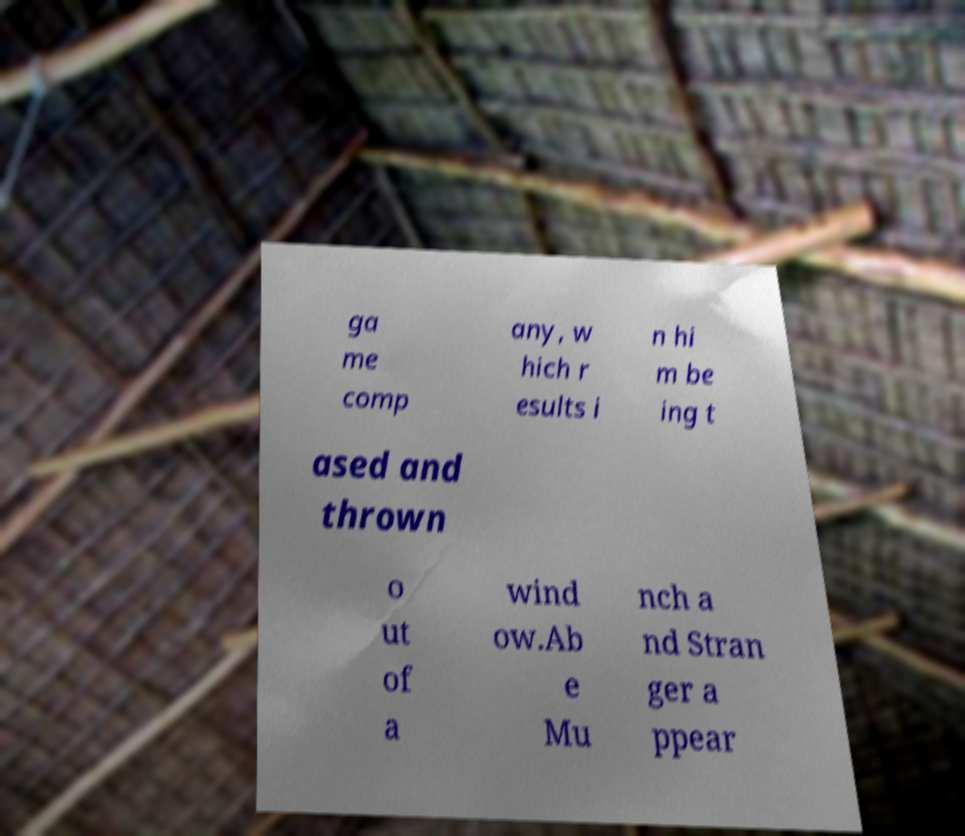Could you assist in decoding the text presented in this image and type it out clearly? ga me comp any, w hich r esults i n hi m be ing t ased and thrown o ut of a wind ow.Ab e Mu nch a nd Stran ger a ppear 